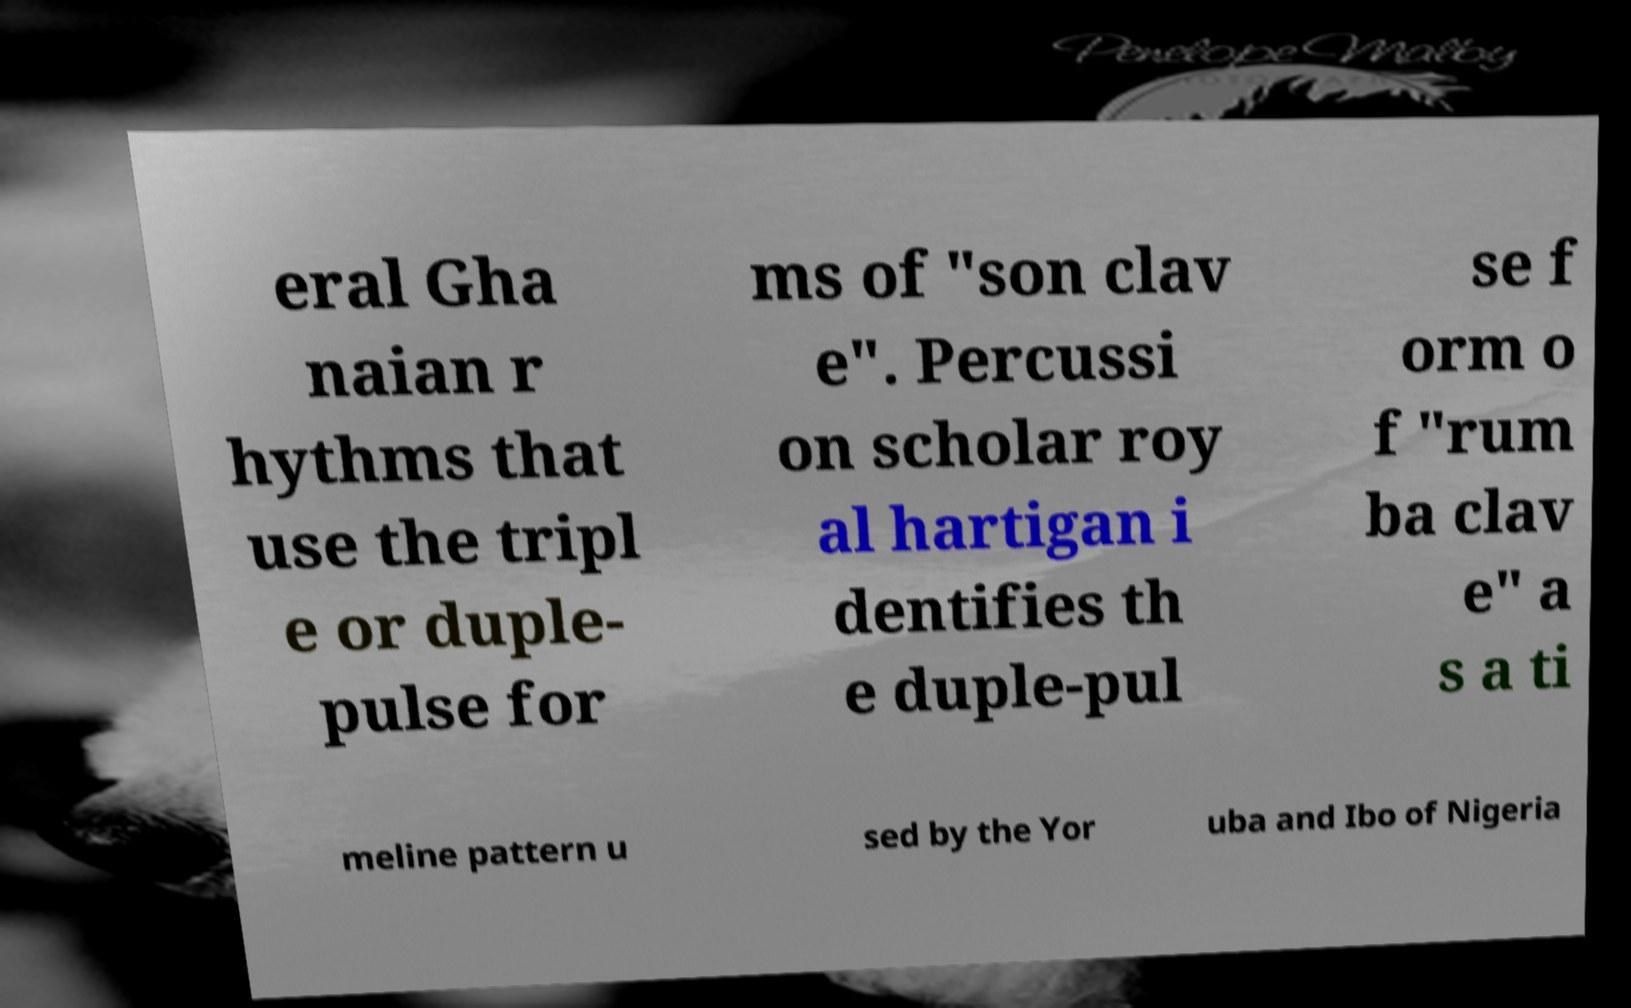Please read and relay the text visible in this image. What does it say? eral Gha naian r hythms that use the tripl e or duple- pulse for ms of "son clav e". Percussi on scholar roy al hartigan i dentifies th e duple-pul se f orm o f "rum ba clav e" a s a ti meline pattern u sed by the Yor uba and Ibo of Nigeria 